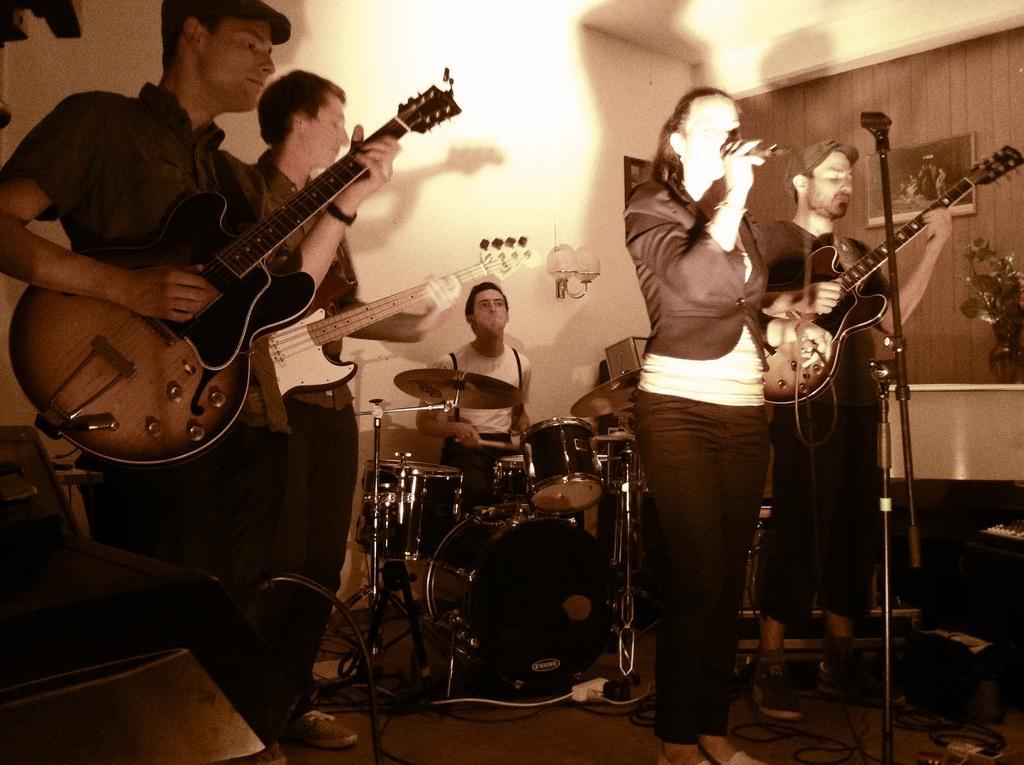Please provide a concise description of this image. In the picture I can see four persons standing where three among them are playing guitar and the remaining one is singing in front of a mic and there is a person sitting is playing drums in the background. 